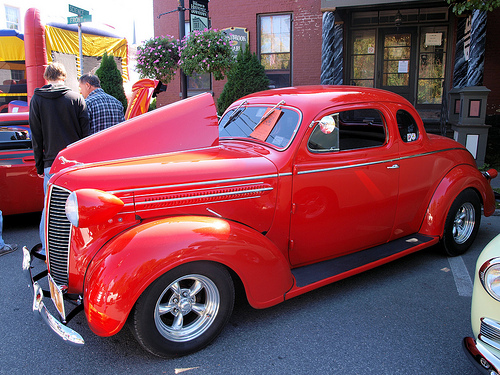<image>
Is there a car in front of the person? Yes. The car is positioned in front of the person, appearing closer to the camera viewpoint. 